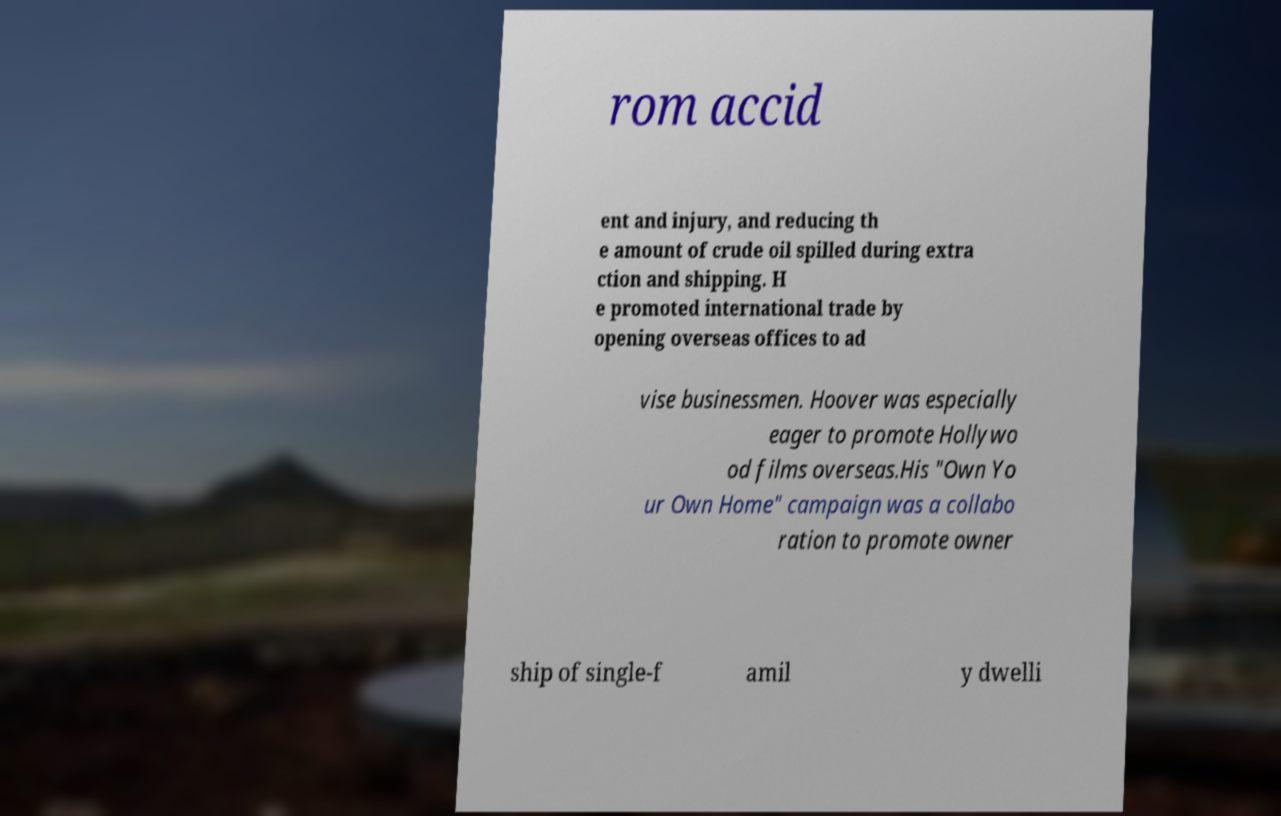There's text embedded in this image that I need extracted. Can you transcribe it verbatim? rom accid ent and injury, and reducing th e amount of crude oil spilled during extra ction and shipping. H e promoted international trade by opening overseas offices to ad vise businessmen. Hoover was especially eager to promote Hollywo od films overseas.His "Own Yo ur Own Home" campaign was a collabo ration to promote owner ship of single-f amil y dwelli 